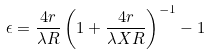Convert formula to latex. <formula><loc_0><loc_0><loc_500><loc_500>\epsilon = \frac { 4 r } { \lambda R } \left ( 1 + \frac { 4 r } { \lambda X R } \right ) ^ { - 1 } - 1</formula> 